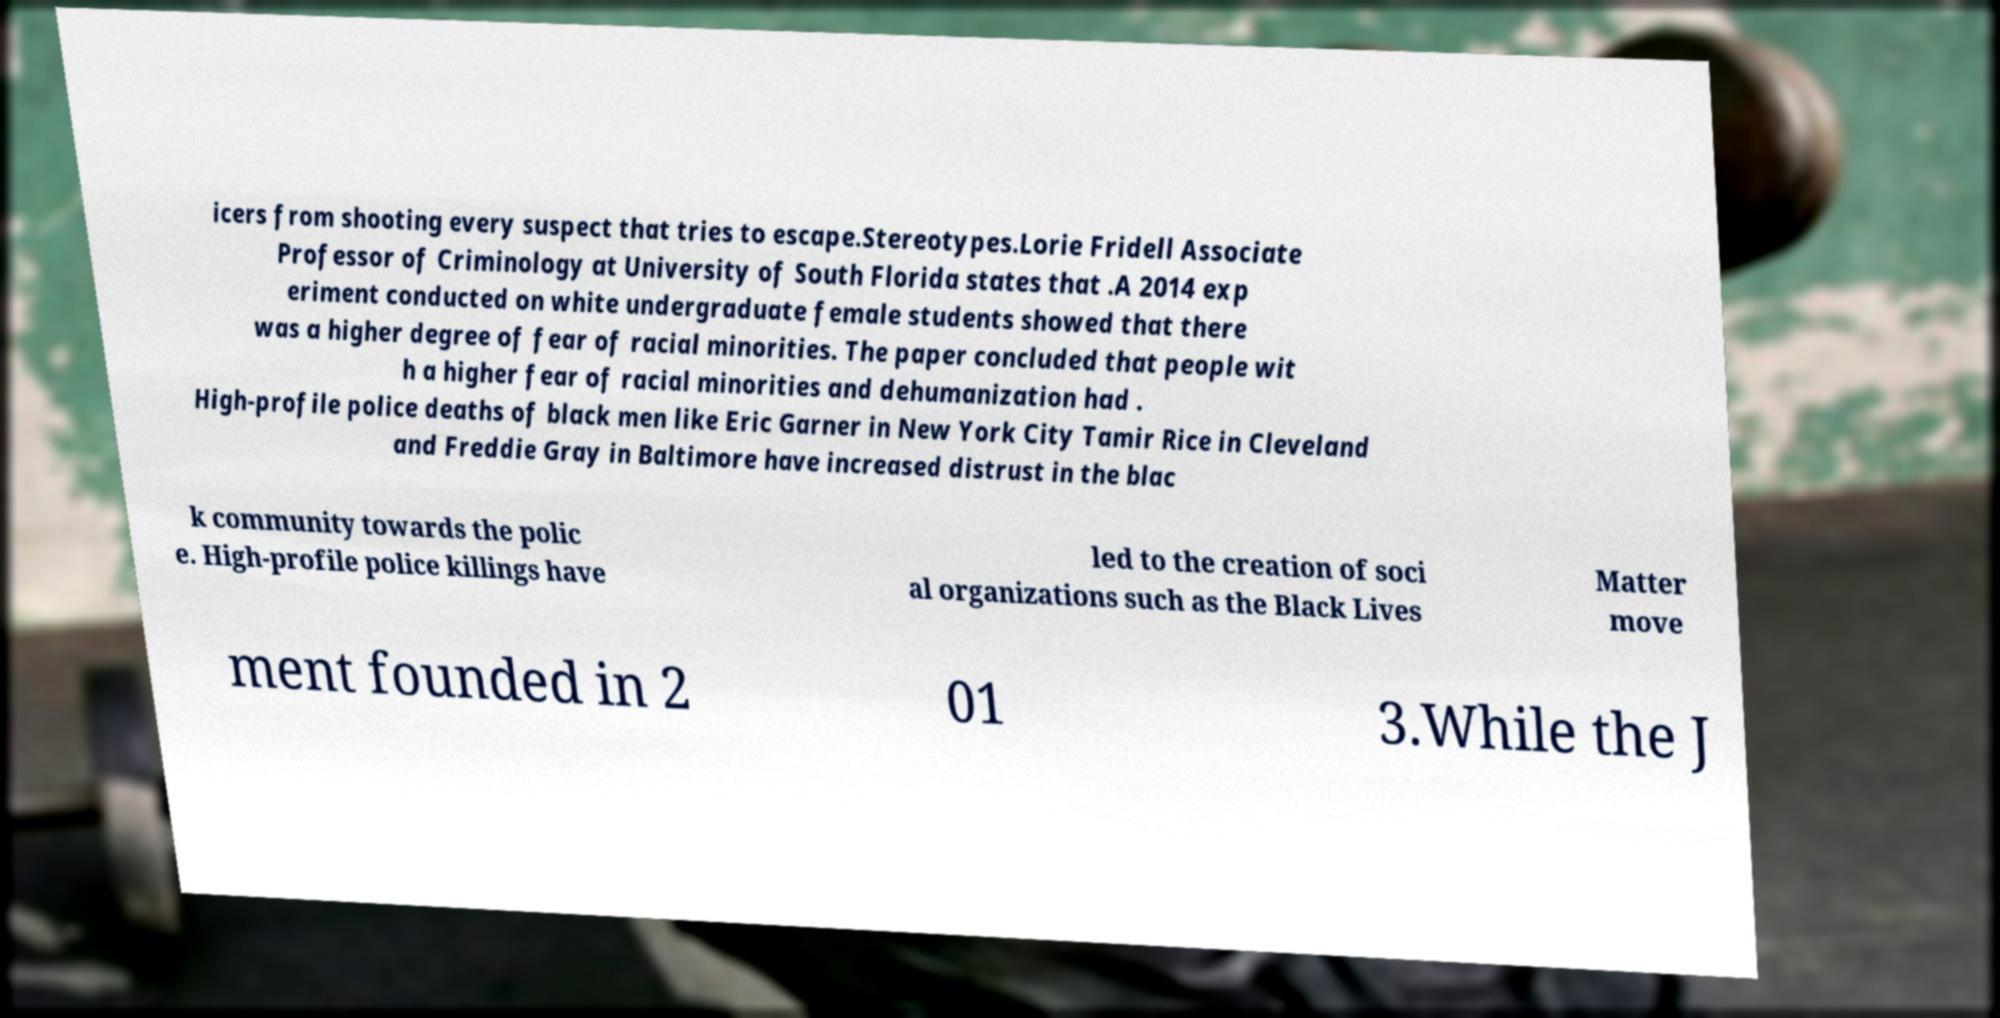There's text embedded in this image that I need extracted. Can you transcribe it verbatim? icers from shooting every suspect that tries to escape.Stereotypes.Lorie Fridell Associate Professor of Criminology at University of South Florida states that .A 2014 exp eriment conducted on white undergraduate female students showed that there was a higher degree of fear of racial minorities. The paper concluded that people wit h a higher fear of racial minorities and dehumanization had . High-profile police deaths of black men like Eric Garner in New York City Tamir Rice in Cleveland and Freddie Gray in Baltimore have increased distrust in the blac k community towards the polic e. High-profile police killings have led to the creation of soci al organizations such as the Black Lives Matter move ment founded in 2 01 3.While the J 